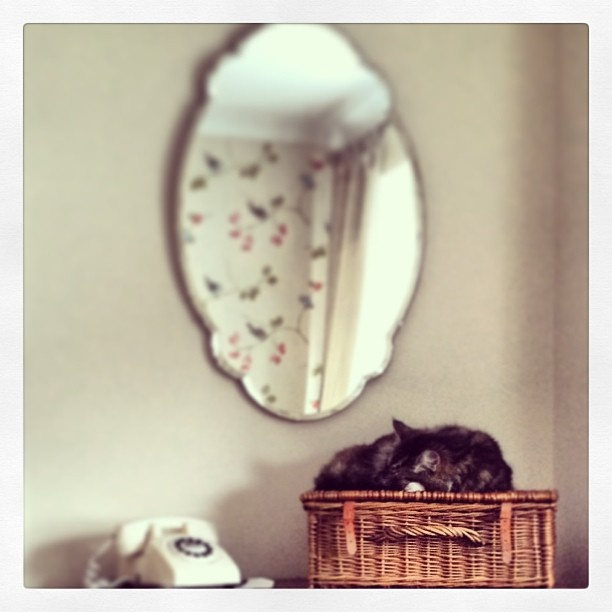Describe the objects in this image and their specific colors. I can see a cat in white, black, purple, and brown tones in this image. 